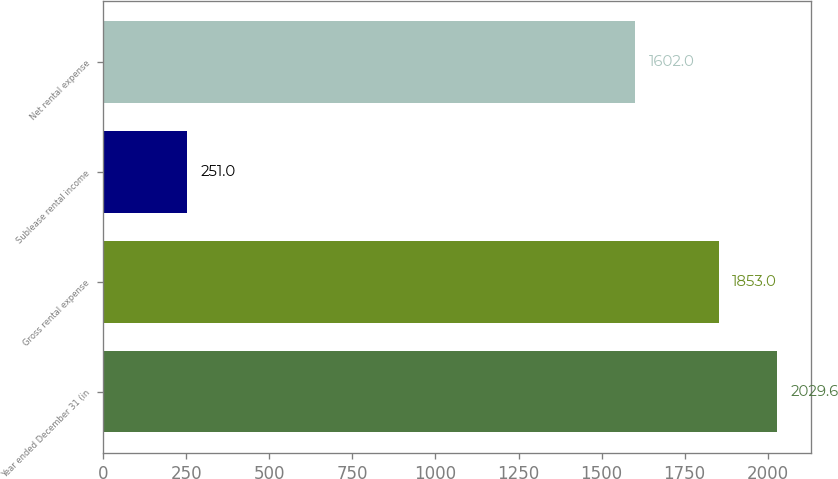Convert chart. <chart><loc_0><loc_0><loc_500><loc_500><bar_chart><fcel>Year ended December 31 (in<fcel>Gross rental expense<fcel>Sublease rental income<fcel>Net rental expense<nl><fcel>2029.6<fcel>1853<fcel>251<fcel>1602<nl></chart> 